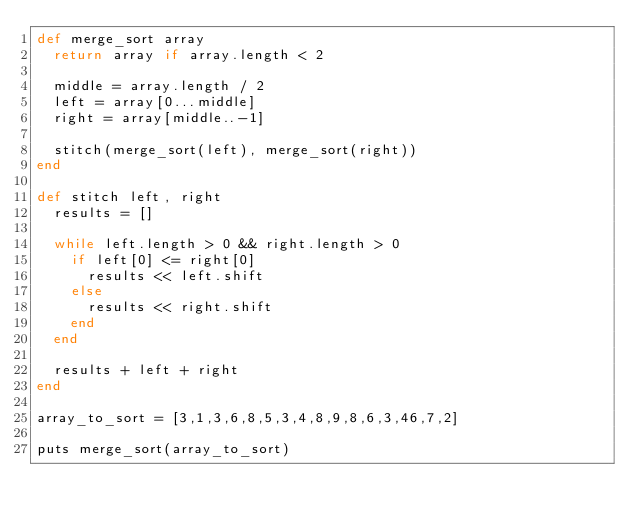<code> <loc_0><loc_0><loc_500><loc_500><_Ruby_>def merge_sort array
	return array if array.length < 2

	middle = array.length / 2
	left = array[0...middle]
	right = array[middle..-1]

	stitch(merge_sort(left), merge_sort(right))
end

def stitch left, right
	results = []

	while left.length > 0 && right.length > 0
		if left[0] <= right[0]
			results << left.shift
		else
			results << right.shift
		end
	end

	results + left + right
end

array_to_sort = [3,1,3,6,8,5,3,4,8,9,8,6,3,46,7,2]

puts merge_sort(array_to_sort)
</code> 